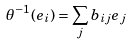<formula> <loc_0><loc_0><loc_500><loc_500>\theta ^ { - 1 } ( e _ { i } ) = \sum _ { j } b _ { i j } e _ { j }</formula> 